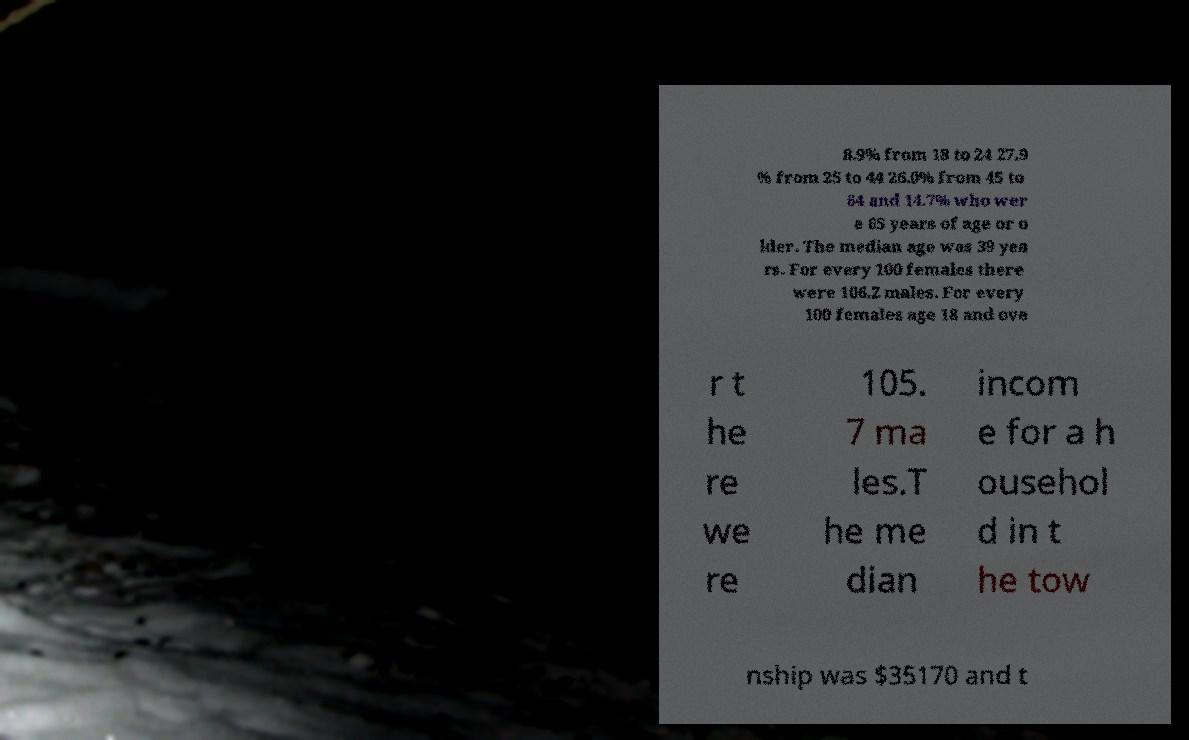Could you assist in decoding the text presented in this image and type it out clearly? 8.9% from 18 to 24 27.9 % from 25 to 44 26.0% from 45 to 64 and 14.7% who wer e 65 years of age or o lder. The median age was 39 yea rs. For every 100 females there were 106.2 males. For every 100 females age 18 and ove r t he re we re 105. 7 ma les.T he me dian incom e for a h ousehol d in t he tow nship was $35170 and t 